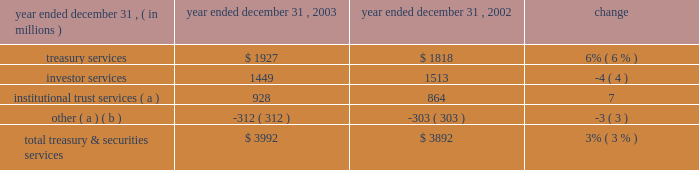J.p .
Morgan chase & co .
/ 2003 annual report 33 corporate credit allocation in 2003 , tss was assigned a corporate credit allocation of pre- tax earnings and the associated capital related to certain credit exposures managed within ib 2019s credit portfolio on behalf of clients shared with tss .
Prior periods have been revised to reflect this allocation .
For 2003 , the impact to tss of this change increased pre-tax operating results by $ 36 million and average allocated capital by $ 712 million , and it decreased sva by $ 65 million .
Pre-tax operating results were $ 46 million lower than in 2002 , reflecting lower loan volumes and higher related expenses , slightly offset by a decrease in credit costs .
Business outlook tss revenue in 2004 is expected to benefit from improved global equity markets and from two recent acquisitions : the november 2003 acquisition of the bank one corporate trust portfolio , and the january 2004 acquisition of citigroup 2019s electronic funds services business .
Tss also expects higher costs as it integrates these acquisitions and continues strategic investments to sup- port business expansion .
By client segment tss dimensions of 2003 revenue diversification by business revenue by geographic region investor services 36% ( 36 % ) other 1% ( 1 % ) institutional trust services 23% ( 23 % ) treasury services 40% ( 40 % ) large corporations 21% ( 21 % ) middle market 18% ( 18 % ) banks 11% ( 11 % ) nonbank financial institutions 44% ( 44 % ) public sector/governments 6% ( 6 % ) europe , middle east & africa 27% ( 27 % ) asia/pacific 9% ( 9 % ) the americas 64% ( 64 % ) ( a ) includes the elimination of revenue related to shared activities with chase middle market in the amount of $ 347 million .
Year ended december 31 , operating revenue .
( a ) includes a portion of the $ 41 million gain on sale of a nonstrategic business in 2003 : $ 1 million in institutional trust services and $ 40 million in other .
( b ) includes the elimination of revenues related to shared activities with chase middle market , and a $ 50 million gain on sale of a non-u.s .
Securities clearing firm in 2002. .
For 2003 , treasury services was how much of the total total treasury & securities services operating revenue? 
Computations: (1927 / 3992)
Answer: 0.48272. 